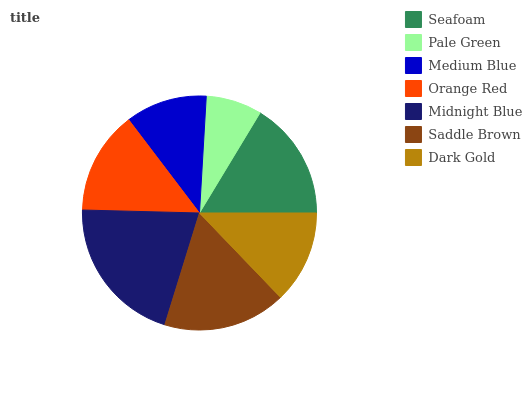Is Pale Green the minimum?
Answer yes or no. Yes. Is Midnight Blue the maximum?
Answer yes or no. Yes. Is Medium Blue the minimum?
Answer yes or no. No. Is Medium Blue the maximum?
Answer yes or no. No. Is Medium Blue greater than Pale Green?
Answer yes or no. Yes. Is Pale Green less than Medium Blue?
Answer yes or no. Yes. Is Pale Green greater than Medium Blue?
Answer yes or no. No. Is Medium Blue less than Pale Green?
Answer yes or no. No. Is Orange Red the high median?
Answer yes or no. Yes. Is Orange Red the low median?
Answer yes or no. Yes. Is Medium Blue the high median?
Answer yes or no. No. Is Medium Blue the low median?
Answer yes or no. No. 